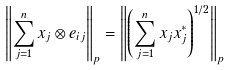<formula> <loc_0><loc_0><loc_500><loc_500>\left \| \sum _ { j = 1 } ^ { n } x _ { j } \otimes e _ { i j } \right \| _ { p } = \left \| \left ( \sum _ { j = 1 } ^ { n } x _ { j } x _ { j } ^ { * } \right ) ^ { 1 / 2 } \right \| _ { p }</formula> 